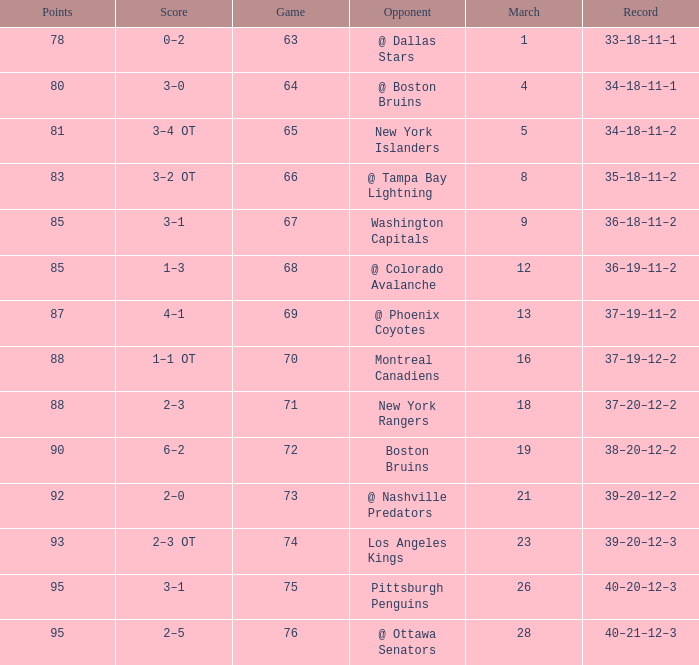Which Game is the highest one that has Points smaller than 92, and a Score of 1–3? 68.0. 